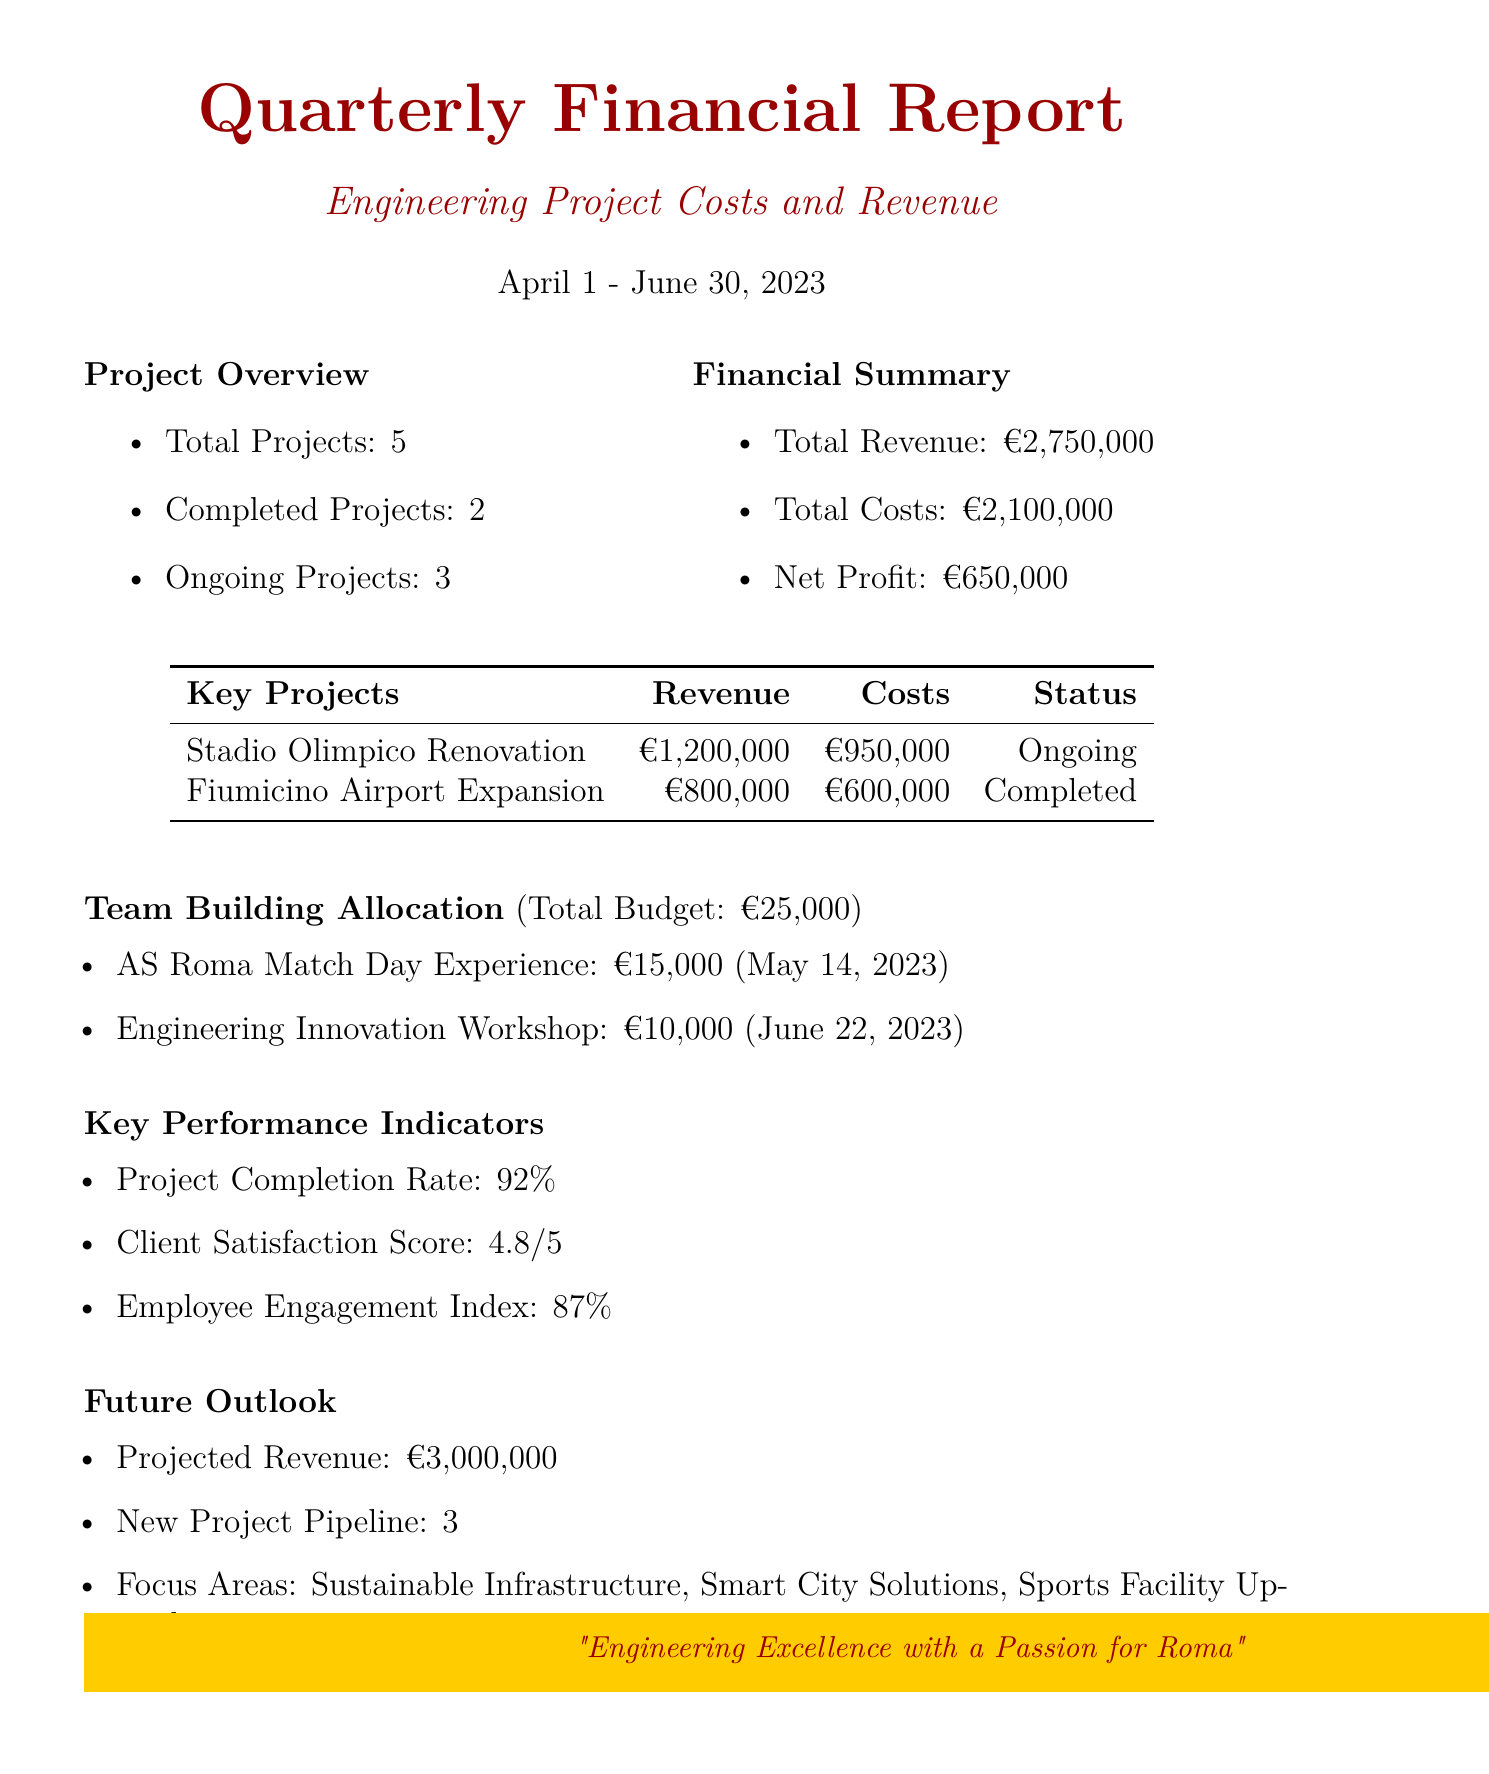what is the total revenue? The total revenue is stated in the financial summary of the report and is given as €2,750,000.
Answer: €2,750,000 what is the net profit? The net profit is calculated as total revenue minus total costs and is stated in the financial summary.
Answer: €650,000 how many ongoing projects are there? The project overview section of the report lists the number of ongoing projects, which is 3.
Answer: 3 what was the cost of the AS Roma Match Day Experience? The team-building allocation includes activities with specific costs, where the AS Roma Match Day Experience cost is given as €15,000.
Answer: €15,000 what is the projected revenue for the next quarter? The future outlook section specifies the projected revenue, which is €3,000,000.
Answer: €3,000,000 what is the client satisfaction score? The key performance indicators include various metrics, one of which lists the client satisfaction score as 4.8/5.
Answer: 4.8/5 which project has the highest revenue? Among the key projects listed, the project with the highest revenue is the Stadio Olimpico Renovation at €1,200,000.
Answer: Stadio Olimpico Renovation what percentage is the project completion rate? The key performance indicators include a metric for the project completion rate, which is stated as 92%.
Answer: 92% what is the total budget for team-building activities? The team-building allocation section specifies a total budget of €25,000 for activities.
Answer: €25,000 